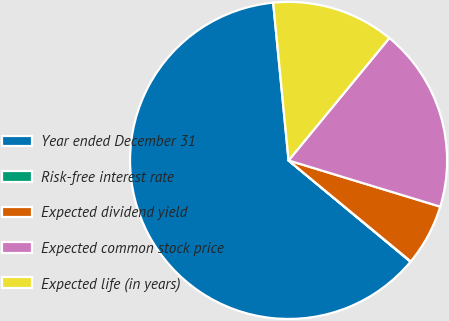<chart> <loc_0><loc_0><loc_500><loc_500><pie_chart><fcel>Year ended December 31<fcel>Risk-free interest rate<fcel>Expected dividend yield<fcel>Expected common stock price<fcel>Expected life (in years)<nl><fcel>62.42%<fcel>0.04%<fcel>6.28%<fcel>18.75%<fcel>12.51%<nl></chart> 